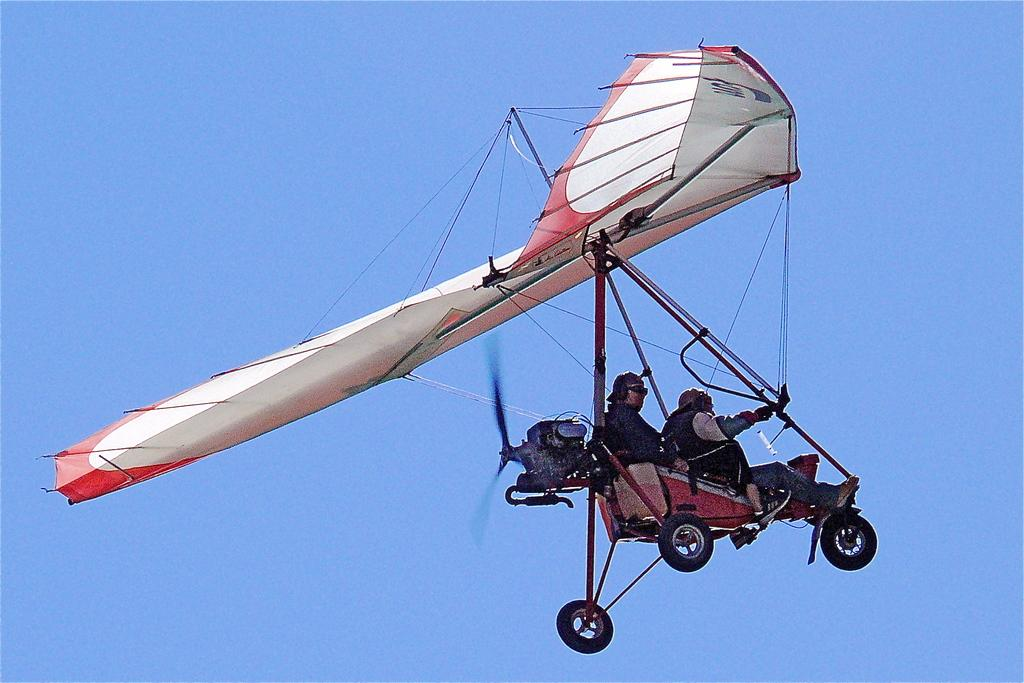What is the main subject of the image? The main subject of the image is an aircraft. Are there any people inside the aircraft? Yes, two persons are sitting in the aircraft. What can be seen in the background of the image? The sky is visible in the background of the image. Can you see any cobwebs in the image? There are no cobwebs present in the image. What type of poison is being used by the aircraft in the image? There is no mention of poison in the image, as it features an aircraft with two persons inside. 